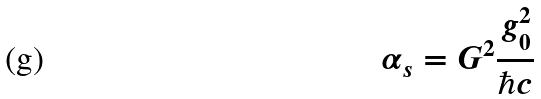Convert formula to latex. <formula><loc_0><loc_0><loc_500><loc_500>\alpha _ { s } = G ^ { 2 } \frac { g _ { 0 } ^ { 2 } } { \hbar { c } }</formula> 